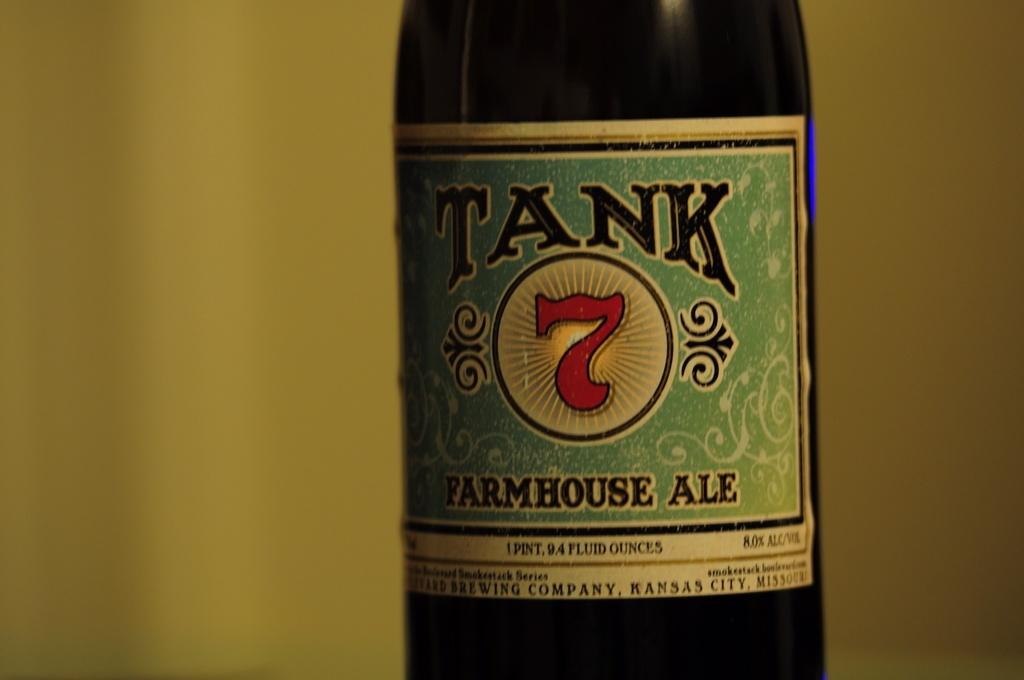<image>
Summarize the visual content of the image. A brown bottle of FarmHouse Ale called Tank 7. 